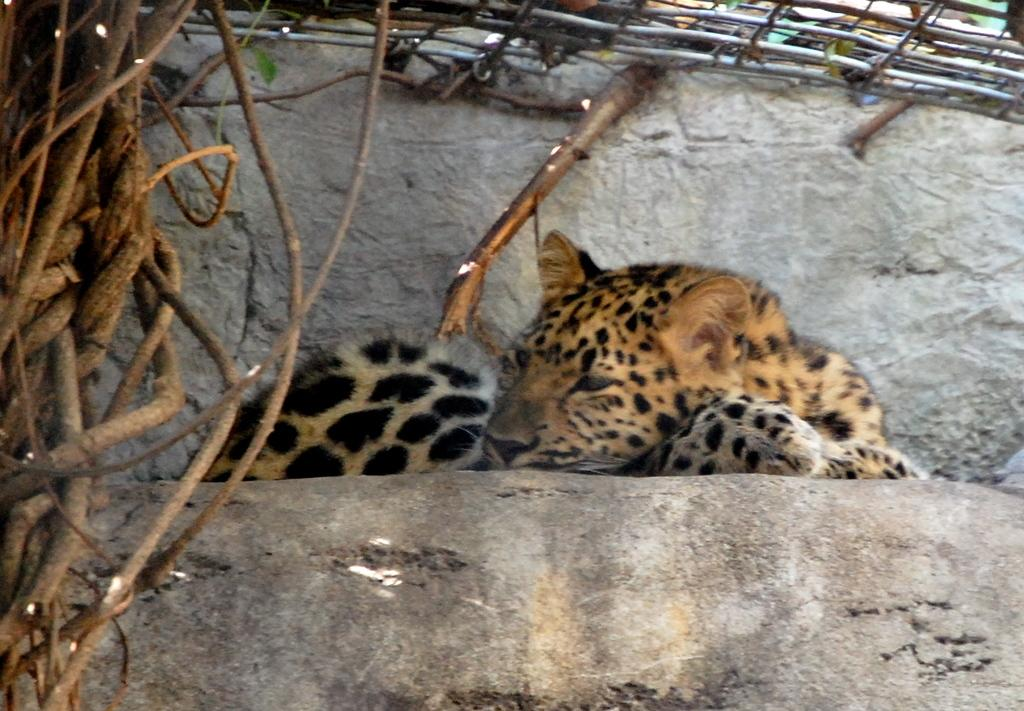What animal can be seen in the image? There is a leopard in the image. What is the leopard doing in the image? The leopard is sleeping on a rock. What can be seen in the background of the image? There is a tree and a wall in the background of the image. What type of amusement can be seen in the image? There is no amusement present in the image; it features a leopard sleeping on a rock. Can you tell me what kind of guitar the leopard is playing in the image? There is no guitar present in the image, and the leopard is sleeping, not playing an instrument. 